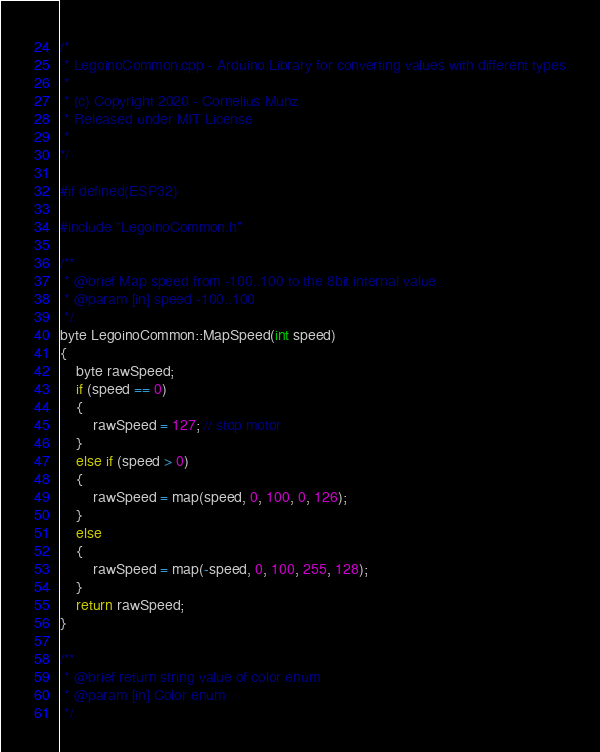<code> <loc_0><loc_0><loc_500><loc_500><_C++_>/*
 * LegoinoCommon.cpp - Arduino Library for converting values with different types
 *
 * (c) Copyright 2020 - Cornelius Munz
 * Released under MIT License
 *
*/

#if defined(ESP32)

#include "LegoinoCommon.h"

/**
 * @brief Map speed from -100..100 to the 8bit internal value
 * @param [in] speed -100..100
 */
byte LegoinoCommon::MapSpeed(int speed)
{
    byte rawSpeed;
    if (speed == 0)
    {
        rawSpeed = 127; // stop motor
    }
    else if (speed > 0)
    {
        rawSpeed = map(speed, 0, 100, 0, 126);
    }
    else
    {
        rawSpeed = map(-speed, 0, 100, 255, 128);
    }
    return rawSpeed;
}

/**
 * @brief return string value of color enum
 * @param [in] Color enum
 */</code> 